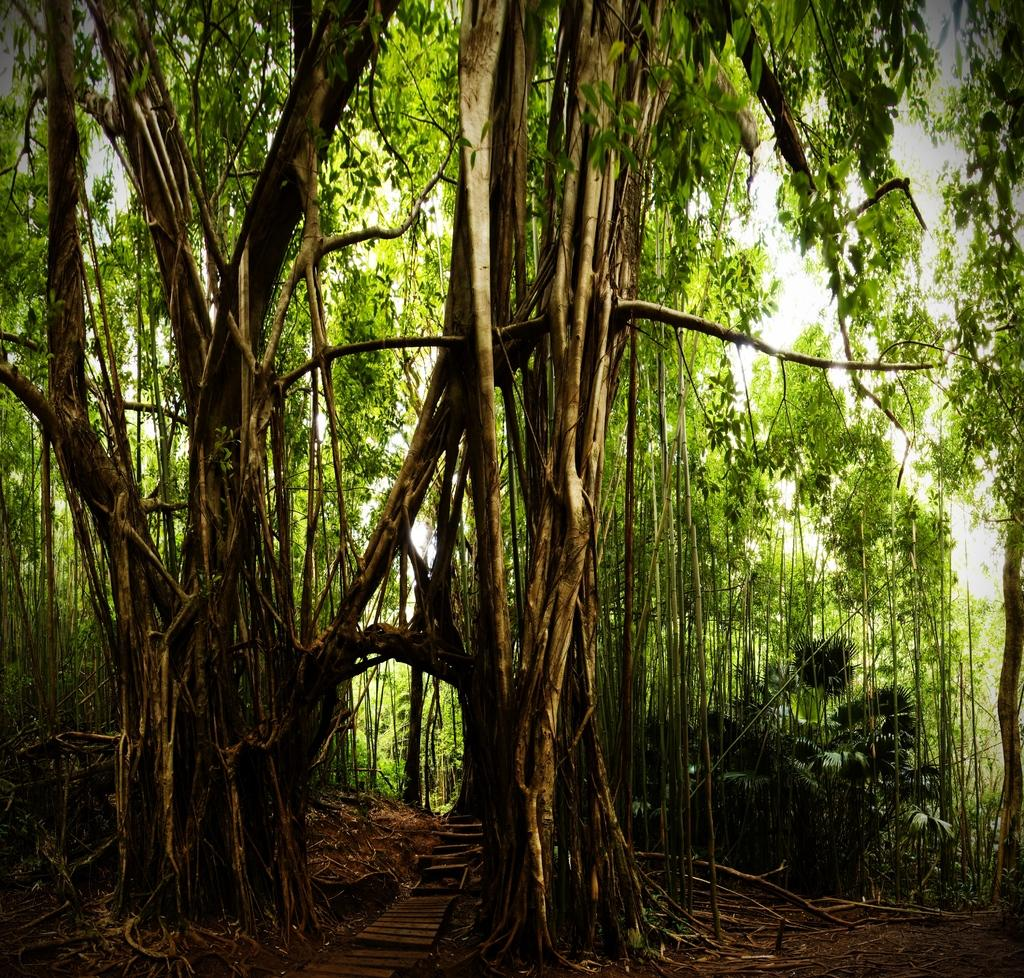What type of vegetation can be seen in the image? There are trees in the image. Can you describe the trees in the image? The provided facts do not include specific details about the trees, so we cannot describe them further. What is your brother's favorite insect, and can it be seen in the image? There is no reference to a brother or an insect in the image, so we cannot answer that question. 